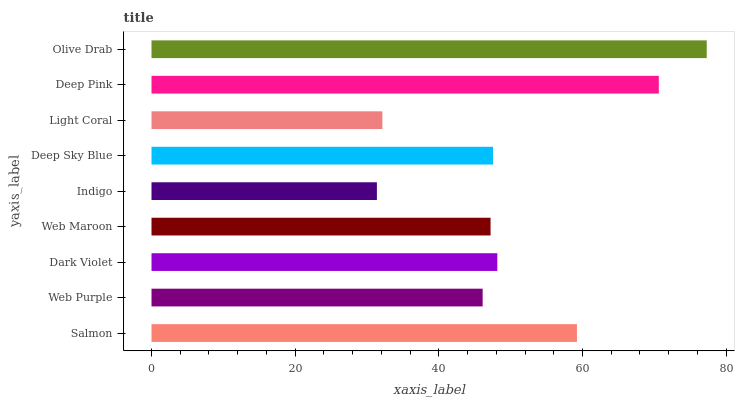Is Indigo the minimum?
Answer yes or no. Yes. Is Olive Drab the maximum?
Answer yes or no. Yes. Is Web Purple the minimum?
Answer yes or no. No. Is Web Purple the maximum?
Answer yes or no. No. Is Salmon greater than Web Purple?
Answer yes or no. Yes. Is Web Purple less than Salmon?
Answer yes or no. Yes. Is Web Purple greater than Salmon?
Answer yes or no. No. Is Salmon less than Web Purple?
Answer yes or no. No. Is Deep Sky Blue the high median?
Answer yes or no. Yes. Is Deep Sky Blue the low median?
Answer yes or no. Yes. Is Web Maroon the high median?
Answer yes or no. No. Is Salmon the low median?
Answer yes or no. No. 